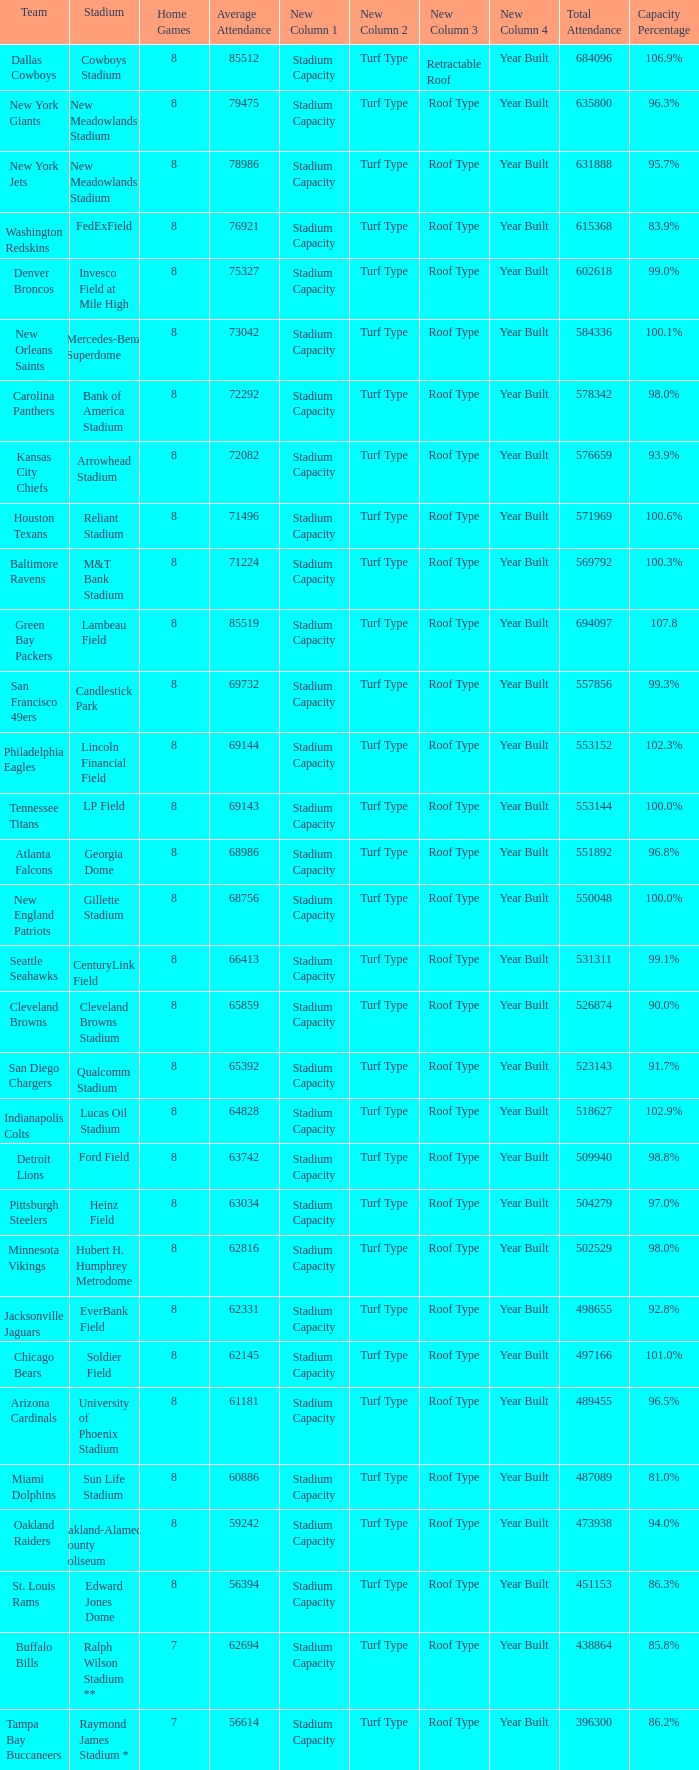What is the capacity percentage when the total attendance is 509940? 98.8%. 